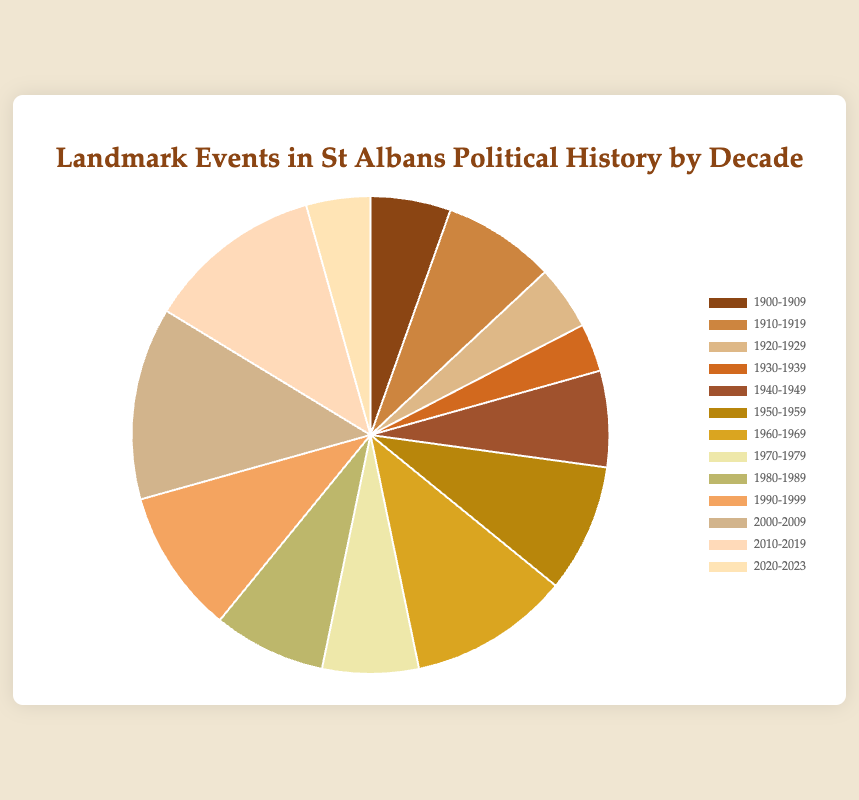Which decade had the highest number of landmark events? By observing the slices of the pie chart, we see that the slice representing the decade 2000-2009 is the largest. This indicates that 2000-2009 had the highest number of landmark events.
Answer: 2000-2009 What is the total number of landmark events from 1960-1969 and 2010-2019 combined? From the chart, we see that 1960-1969 had 10 events and 2010-2019 had 11 events. Summing these gives 10 + 11 = 21.
Answer: 21 Which decades had an equal number of landmark events? Observing the pie chart, the 1940-1949 and 1970-1979 slices are the same size, each representing 6 events. Thus, these two decades had equal numbers of landmark events.
Answer: 1940-1949 and 1970-1979 What is the difference in the number of landmark events between the decade with the fewest and the decade with the most events? The decade 1930-1939 has the fewest events at 3, and the decade 2000-2009 has the most at 12. The difference is 12 - 3 = 9.
Answer: 9 What is the median number of landmark events per decade? To find the median, we list the number of events in order: [3, 4, 4, 5, 6, 6, 7, 7, 8, 9, 10, 11, 12]. The median is the middle value, so it's the 7th number in this ordered list: 7.
Answer: 7 Which two decades have the closest number of events? Observing the chart, the decades 1960-1969 and 1990-1999 have fairly close values of 10 and 9 events respectively. The difference between them is just 1.
Answer: 1960-1969 and 1990-1999 How many events are there in total from 1900 to 1949? Summing the events from the decades 1900-1909 (5), 1910-1919 (7), 1920-1929 (4), 1930-1939 (3), and 1940-1949 (6) gives 5 + 7 + 4 + 3 + 6 = 25.
Answer: 25 What percentage of the total landmark events occurred from 1990 to 2019? The decades 1990-1999, 2000-2009, and 2010-2019 had 9, 12, and 11 events respectively, totalling 32 events. The sum of all events is 92. The percentage is (32/92) * 100 ≈ 34.78%.
Answer: 34.78% Which decade has the smallest slice on the pie chart? The smallest slice on the pie chart represents the decade 1930-1939, which had 3 landmark events.
Answer: 1930-1939 Visual: What is the color of the slice representing the decade 2000-2009? The particular slice representing the decade 2000-2009 on the pie chart is typically in a distinct color to stand out. For this example, it's colored either dark or saturated to differentiate it significantly.
Answer: (Assume a dark or distinct color depending on provided chart colors) 